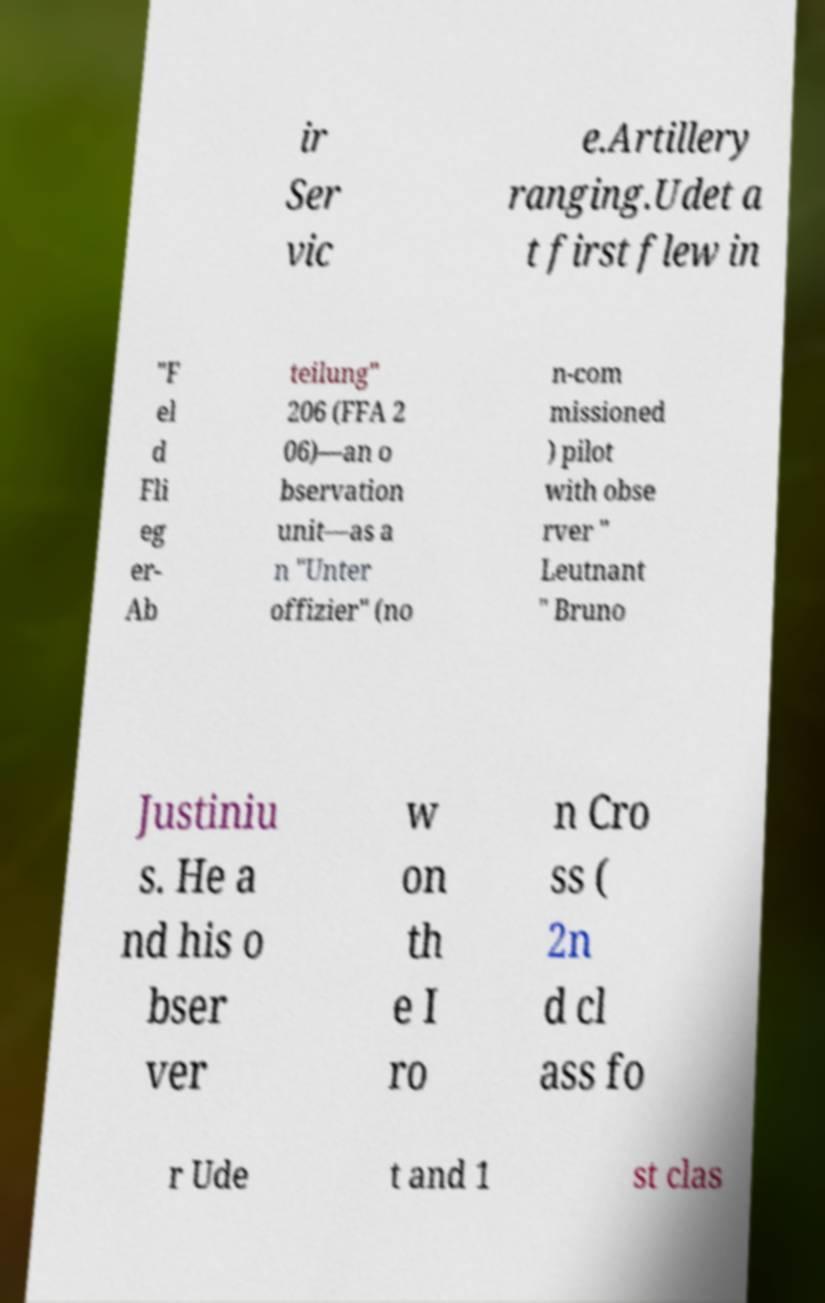Please read and relay the text visible in this image. What does it say? ir Ser vic e.Artillery ranging.Udet a t first flew in "F el d Fli eg er- Ab teilung" 206 (FFA 2 06)—an o bservation unit—as a n "Unter offizier" (no n-com missioned ) pilot with obse rver " Leutnant " Bruno Justiniu s. He a nd his o bser ver w on th e I ro n Cro ss ( 2n d cl ass fo r Ude t and 1 st clas 